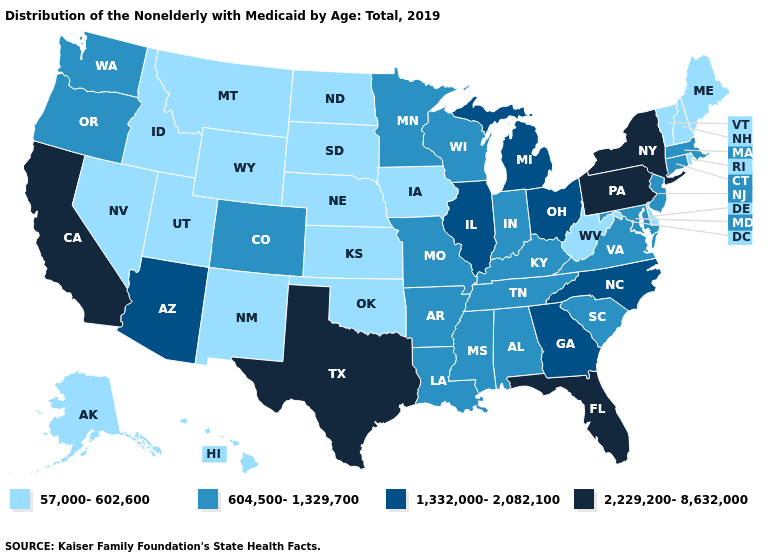Does Nevada have the lowest value in the USA?
Quick response, please. Yes. Does Michigan have a lower value than New Hampshire?
Quick response, please. No. Does Alabama have the same value as New York?
Answer briefly. No. Does Florida have the highest value in the USA?
Give a very brief answer. Yes. Does New Jersey have the same value as Illinois?
Be succinct. No. Does the first symbol in the legend represent the smallest category?
Concise answer only. Yes. What is the value of Florida?
Answer briefly. 2,229,200-8,632,000. Name the states that have a value in the range 2,229,200-8,632,000?
Be succinct. California, Florida, New York, Pennsylvania, Texas. What is the value of North Dakota?
Be succinct. 57,000-602,600. What is the lowest value in states that border New Jersey?
Answer briefly. 57,000-602,600. What is the value of Idaho?
Concise answer only. 57,000-602,600. Which states have the lowest value in the MidWest?
Be succinct. Iowa, Kansas, Nebraska, North Dakota, South Dakota. Does the first symbol in the legend represent the smallest category?
Give a very brief answer. Yes. 